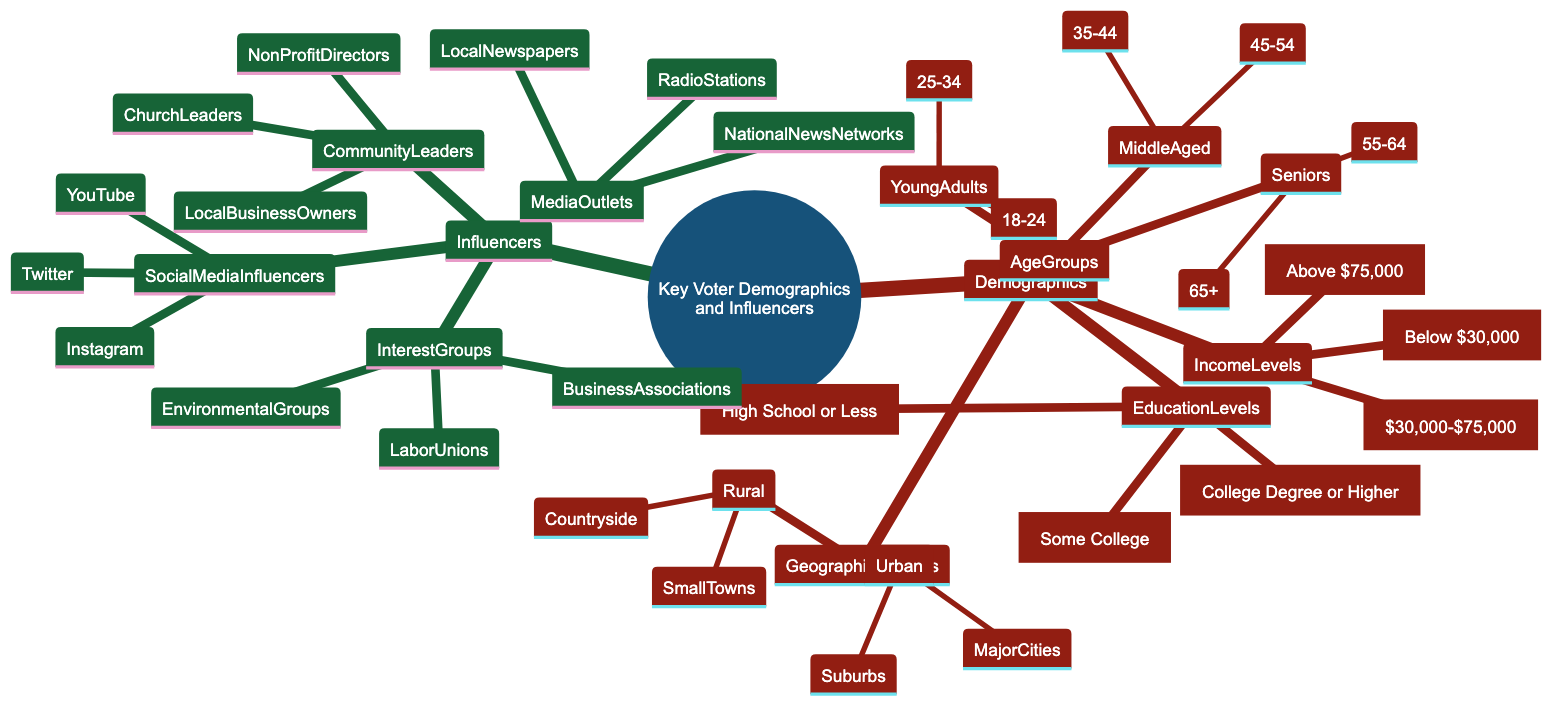What are the age groups classified under Young Adults? The Young Adults category, under the Age Groups node in the diagram, specifies two specific age ranges: 18-24 and 25-34. These are listed directly as children under the Young Adults node.
Answer: 18-24, 25-34 How many income levels are represented in the diagram? To determine this, I count the distinct income levels listed under the Income Levels node: Low Income, Middle Income, and High Income. This gives a total of three.
Answer: 3 What are the geographic regions represented? The Geographic Regions node contains two main regions: Urban and Rural. Under each, there are specific areas listed, but the main regions can be directly identified at this level.
Answer: Urban, Rural What is the highest educational qualification mentioned? By examining the EducationLevels node, I can see that the highest educational qualification is "College Degree or Higher," which is listed as one of the three educational categories.
Answer: College Degree or Higher Which influencers are part of Interest Groups? When looking at the Influencers section, the Interest Groups node specifically lists three types: Labor Unions, Environmental Groups, and Business Associations. These are directly under the Interest Groups node.
Answer: Labor Unions, Environmental Groups, Business Associations How many types of Community Leaders are mentioned in the diagram? Under the Community Leaders node, there are three types specified: Church Leaders, Local Business Owners, and Non-Profit Directors. Counting these gives a total of three.
Answer: 3 Which social media platforms are listed as influencers? The Social Media Influencers node contains three platforms: Instagram, Twitter, and YouTube. Thus, these platforms are identified as the influencers in this category.
Answer: Instagram, Twitter, YouTube What is the relationship between Geographic Regions and Urban areas? The Urban category is a child under the Geographic Regions node, indicating that Urban is a specific subset of the larger category of geographic regions.
Answer: Urban is a subset of Geographic Regions Which group would likely influence voters the most according to the diagram? Analyzing the Influencers section, it can be reasoned that Social Media Influencers, due to their broad reach and impact, would likely have the most influence on voters. They are listed first in the Influencers hierarchy, suggesting significance.
Answer: Social Media Influencers 